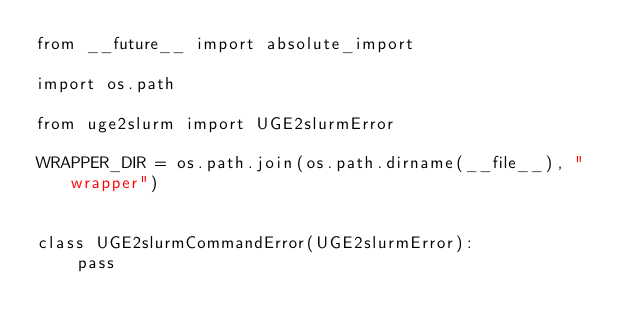<code> <loc_0><loc_0><loc_500><loc_500><_Python_>from __future__ import absolute_import

import os.path

from uge2slurm import UGE2slurmError

WRAPPER_DIR = os.path.join(os.path.dirname(__file__), "wrapper")


class UGE2slurmCommandError(UGE2slurmError):
    pass
</code> 